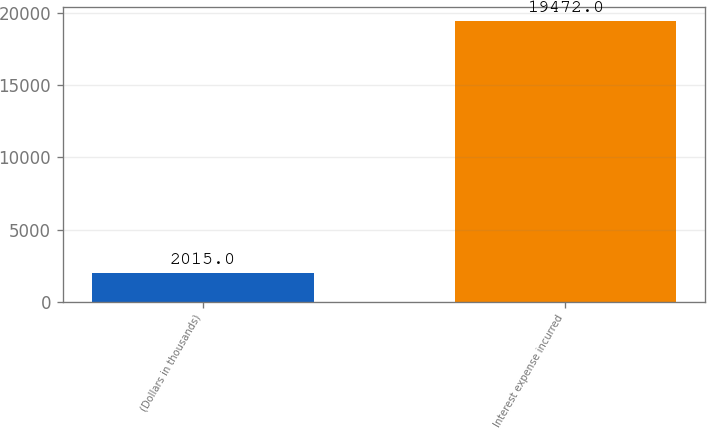<chart> <loc_0><loc_0><loc_500><loc_500><bar_chart><fcel>(Dollars in thousands)<fcel>Interest expense incurred<nl><fcel>2015<fcel>19472<nl></chart> 